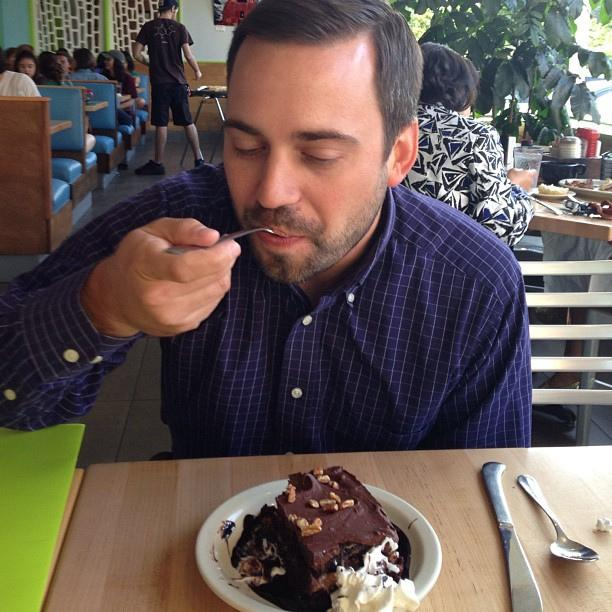What type of restaurant is this?

Choices:
A) chinese
B) diner
C) moroccan
D) tavern diner 